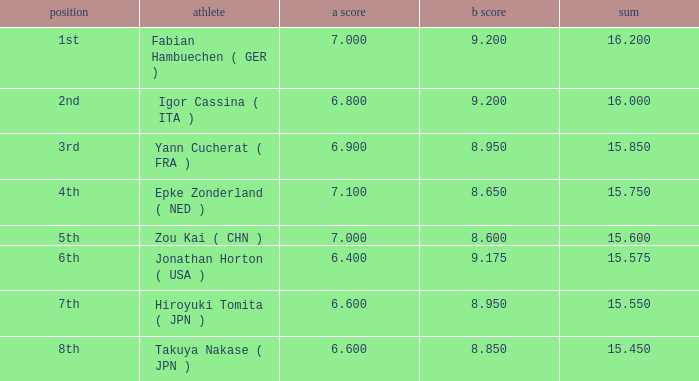Which gymnast had a b score of 8.95 and an a score less than 6.9 Hiroyuki Tomita ( JPN ). 